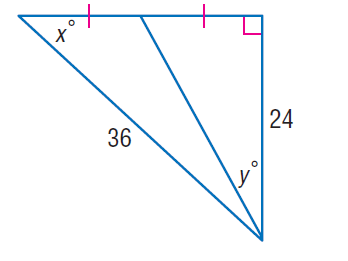Question: Find x.
Choices:
A. 41.8
B. 42.9
C. 67.1
D. 76.4
Answer with the letter. Answer: A 